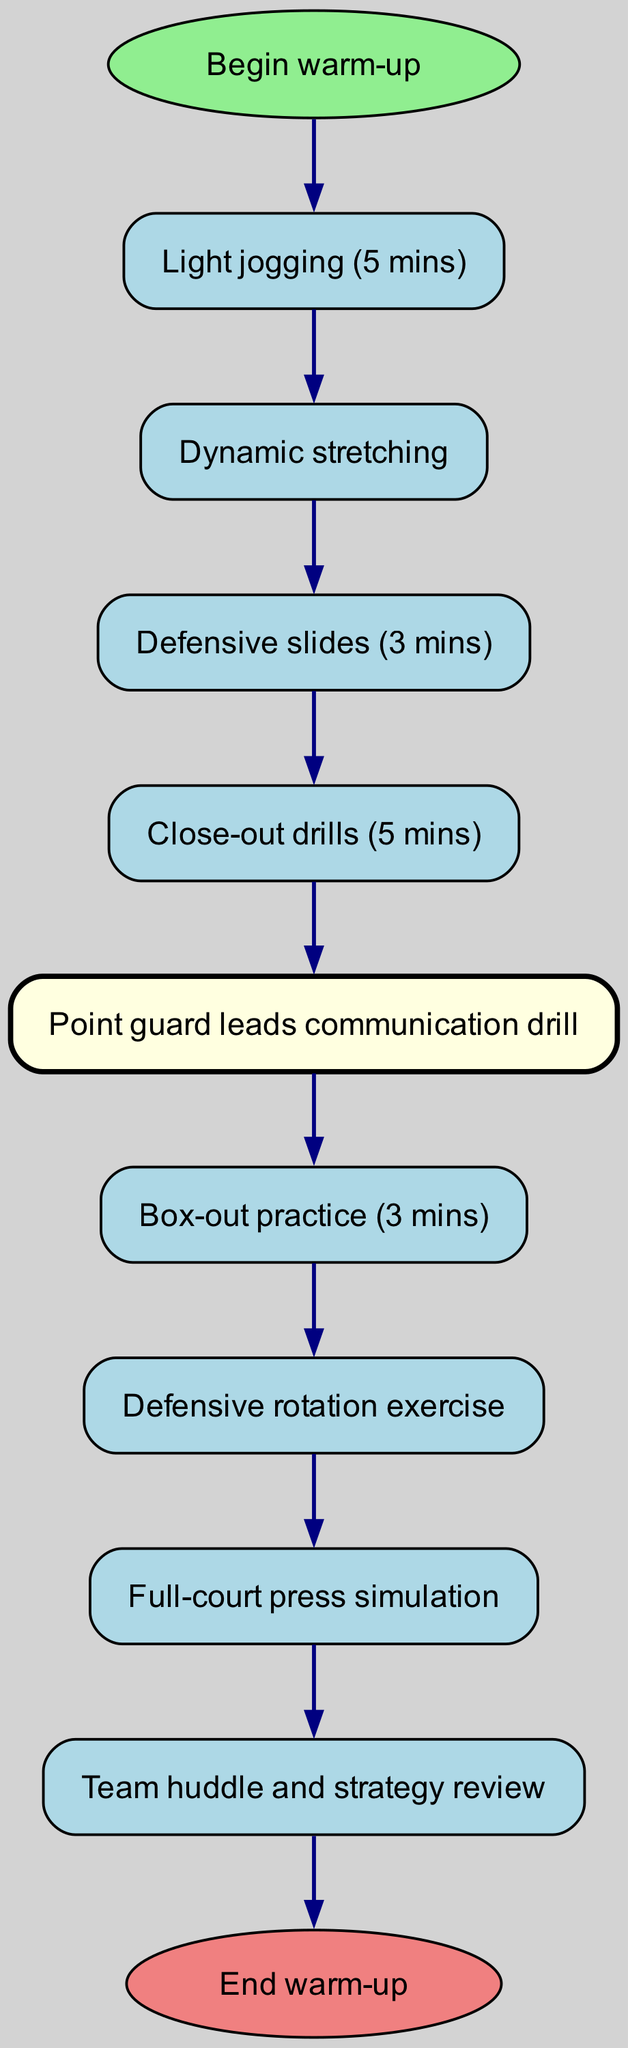What is the first activity in the warm-up routine? The diagram shows that the first activity is labeled "Light jogging (5 mins)" which is directly linked from the start node "Begin warm-up."
Answer: Light jogging (5 mins) How many defensive drills are included in the routine? By examining the nodes specifically mentioning defensive activities, we find that there are four defensive drills: "Defensive slides (3 mins)", "Close-out drills (5 mins)", "Box-out practice (3 mins)", and "Defensive rotation exercise".
Answer: Four What is the last activity before the team huddle? The last activity before the team huddle is "Full-court press simulation", which is the final node before the "Team huddle and strategy review".
Answer: Full-court press simulation Which role leads the communication drill? The diagram highlights "Point guard leads communication drill" as the specified activity for the point guard, making it clear that this is the role leading the drill.
Answer: Point guard What is the duration of the defensive slides drill? The corresponding node states that the duration for defensive slides is "3 mins," which can be found directly as the information attached to that specific activity.
Answer: 3 mins How is the "Point guard leads communication drill" connected to the previous activity? The diagram indicates that "Point guard leads communication drill" is directly connected from the "Close-out drills (5 mins)", showing a sequential flow from that activity to the communication drill.
Answer: Close-out drills (5 mins) Which activity comes after box-out practice? According to the diagram, the activity following "Box-out practice (3 mins)" is "Defensive rotation exercise", which is next in the sequence of warm-up activities.
Answer: Defensive rotation exercise What color is used to highlight the point guard's role in the diagram? The diagram specifically uses "light yellow" to fill the node representing the point guard's activity, distinguishing it from the other activities.
Answer: Light yellow 